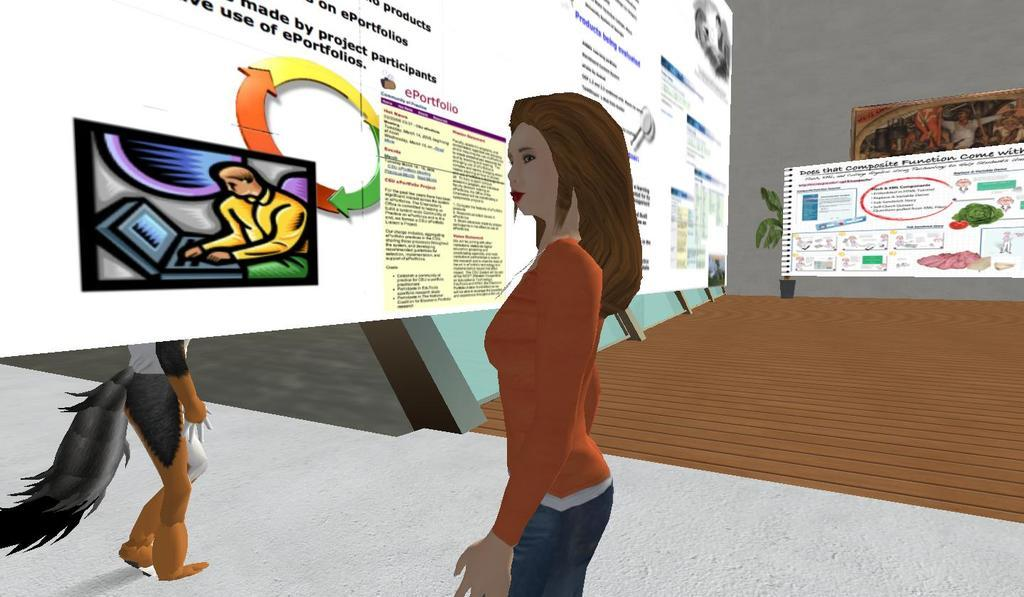What type of content is featured in the image? There is an animation in the image. What elements are included in the animation? The animation includes a wall, a photo frame, and banners. Is there a person present in the animation? Yes, there is a woman standing in the middle of the animation. Are there any animals featured in the animation? Yes, there is an animal on the left side of the animation. What type of club can be seen in the animation? There is no club present in the animation; it features a wall, a photo frame, banners, a woman, and an animal. What scene is depicted in the animation? The animation does not depict a specific scene; it is a combination of various elements, including a wall, a photo frame, banners, a woman, and an animal. 